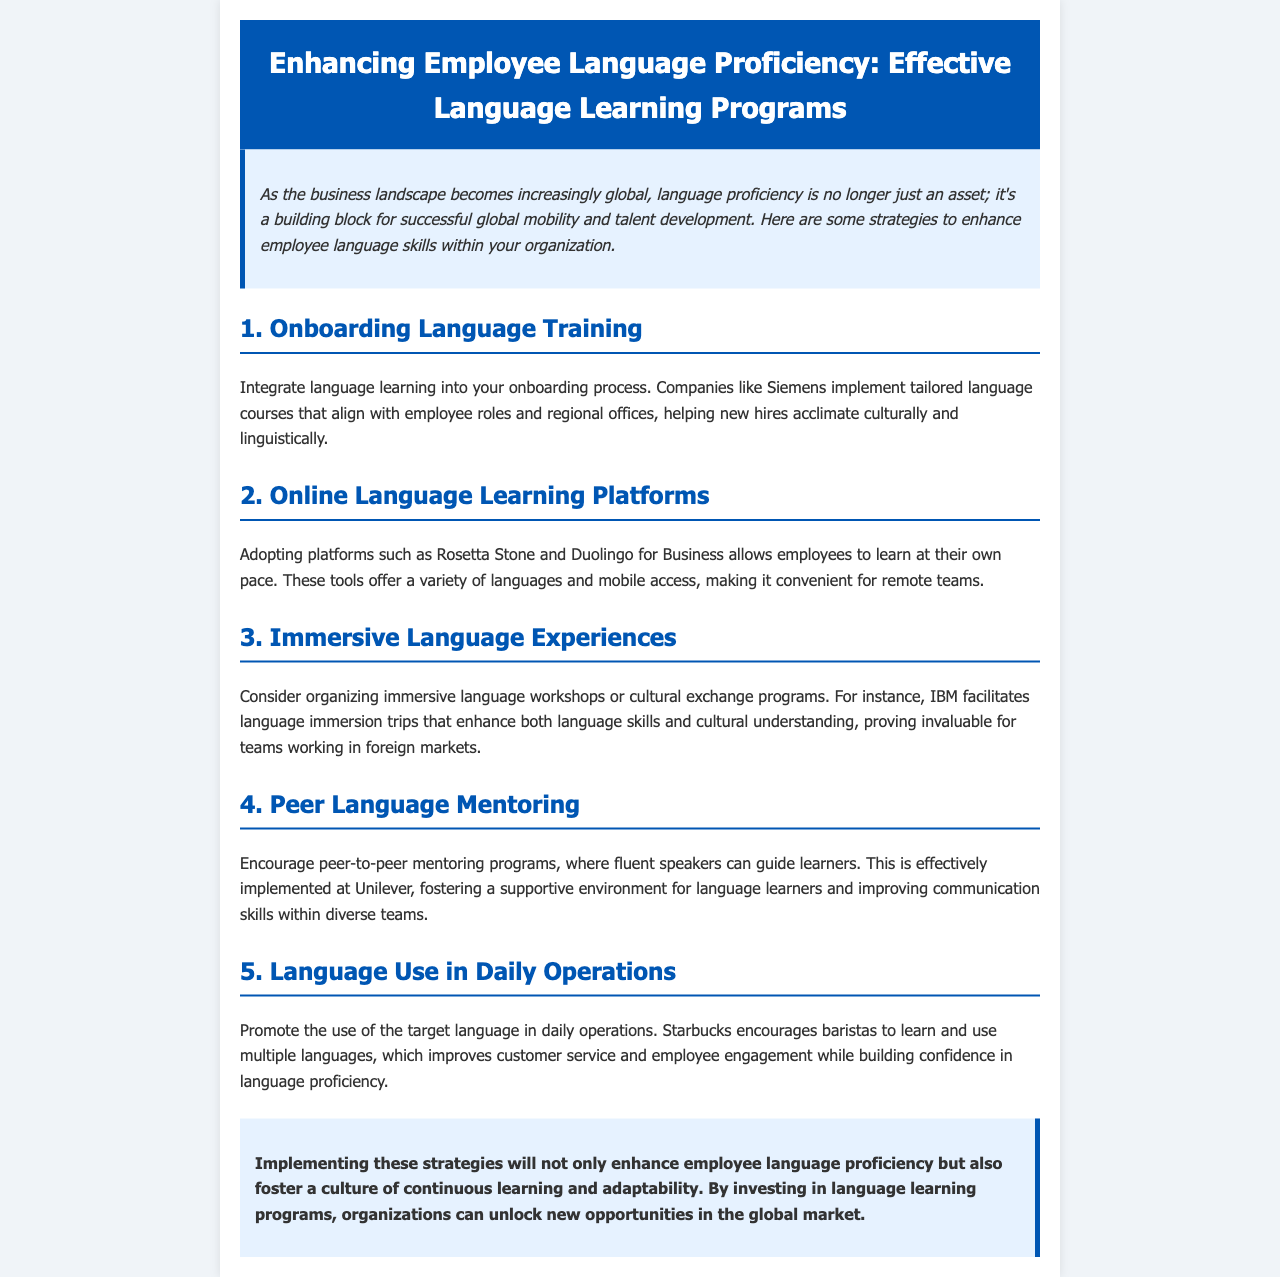What is the title of the newsletter? The title of the newsletter is presented in the header section, emphasizing the focus on language proficiency enhancement.
Answer: Enhancing Employee Language Proficiency: Effective Language Learning Programs Which company is mentioned as implementing tailored language courses? The document lists Siemens as a company that integrates language learning into its onboarding process.
Answer: Siemens What type of platforms are recommended for language learning? The document suggests adopting online platforms such as Rosetta Stone and Duolingo for Business.
Answer: Online Language Learning Platforms What is one strategy for promoting language use in daily operations? The document cites Starbucks encouraging baristas to learn and use multiple languages as a strategy.
Answer: Learning multiple languages Which company organizes immersive language workshops? IBM is mentioned as facilitating language immersion trips for improving language skills and cultural understanding.
Answer: IBM How many strategies are listed in the document? The newsletter enumerates five strategies to enhance employee language proficiency.
Answer: Five What component of talent development is emphasized as a building block? The introduction highlights that language proficiency is a fundamental building block for successful global mobility and talent development.
Answer: Language proficiency What is the color scheme used in the document's header? The header uses a blue background and white text for visual prominence.
Answer: Blue background with white text 